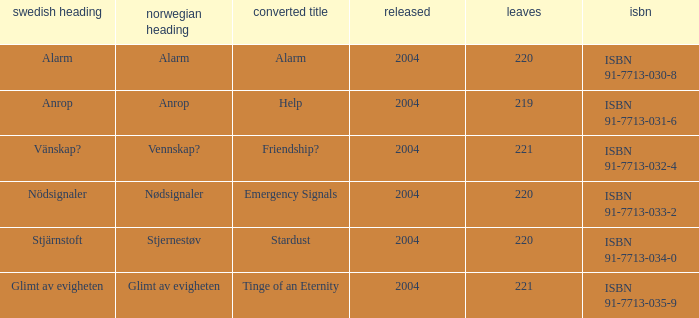How many pages associated with isbn 91-7713-035-9? 221.0. 